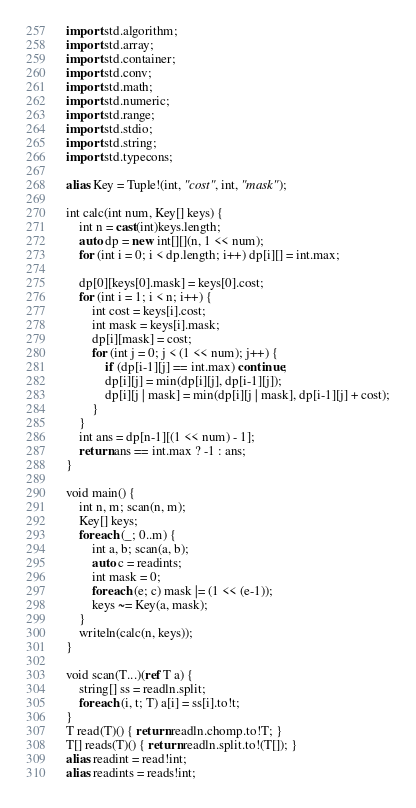Convert code to text. <code><loc_0><loc_0><loc_500><loc_500><_D_>import std.algorithm;
import std.array;
import std.container;
import std.conv;
import std.math;
import std.numeric;
import std.range;
import std.stdio;
import std.string;
import std.typecons;

alias Key = Tuple!(int, "cost", int, "mask");

int calc(int num, Key[] keys) {
    int n = cast(int)keys.length;
    auto dp = new int[][](n, 1 << num);
    for (int i = 0; i < dp.length; i++) dp[i][] = int.max;

    dp[0][keys[0].mask] = keys[0].cost;
    for (int i = 1; i < n; i++) {
        int cost = keys[i].cost;
        int mask = keys[i].mask;
        dp[i][mask] = cost;
        for (int j = 0; j < (1 << num); j++) {
            if (dp[i-1][j] == int.max) continue;
            dp[i][j] = min(dp[i][j], dp[i-1][j]);
            dp[i][j | mask] = min(dp[i][j | mask], dp[i-1][j] + cost);
        }
    }
    int ans = dp[n-1][(1 << num) - 1];
    return ans == int.max ? -1 : ans;
}

void main() {
    int n, m; scan(n, m);
    Key[] keys;
    foreach (_; 0..m) {
        int a, b; scan(a, b);
        auto c = readints;
        int mask = 0;
        foreach (e; c) mask |= (1 << (e-1));
        keys ~= Key(a, mask);
    }
    writeln(calc(n, keys));
}

void scan(T...)(ref T a) {
    string[] ss = readln.split;
    foreach (i, t; T) a[i] = ss[i].to!t;
}
T read(T)() { return readln.chomp.to!T; }
T[] reads(T)() { return readln.split.to!(T[]); }
alias readint = read!int;
alias readints = reads!int;
</code> 